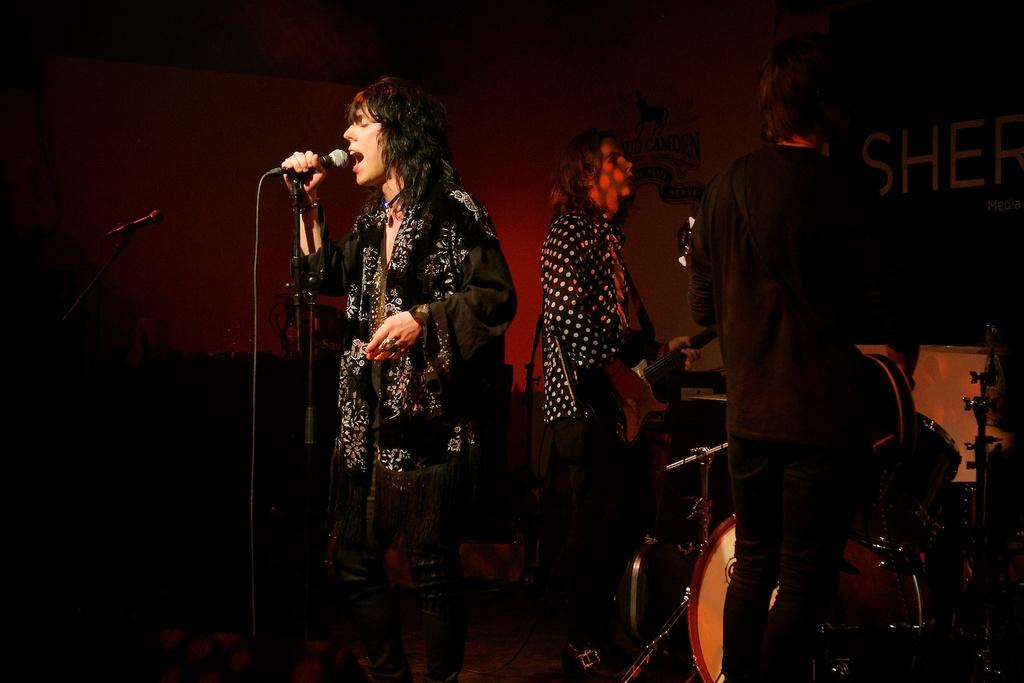What is the person in the image doing? The person is holding a mic and singing in the image. How many people are present in the image? There are two people standing in the image. What can be seen in the background of the image? There is a drum and other musical instruments in the background of the image. What type of sticks can be seen in the image? There are no sticks present in the image. What time of day is it in the image? The time of day is not mentioned or depicted in the image. 